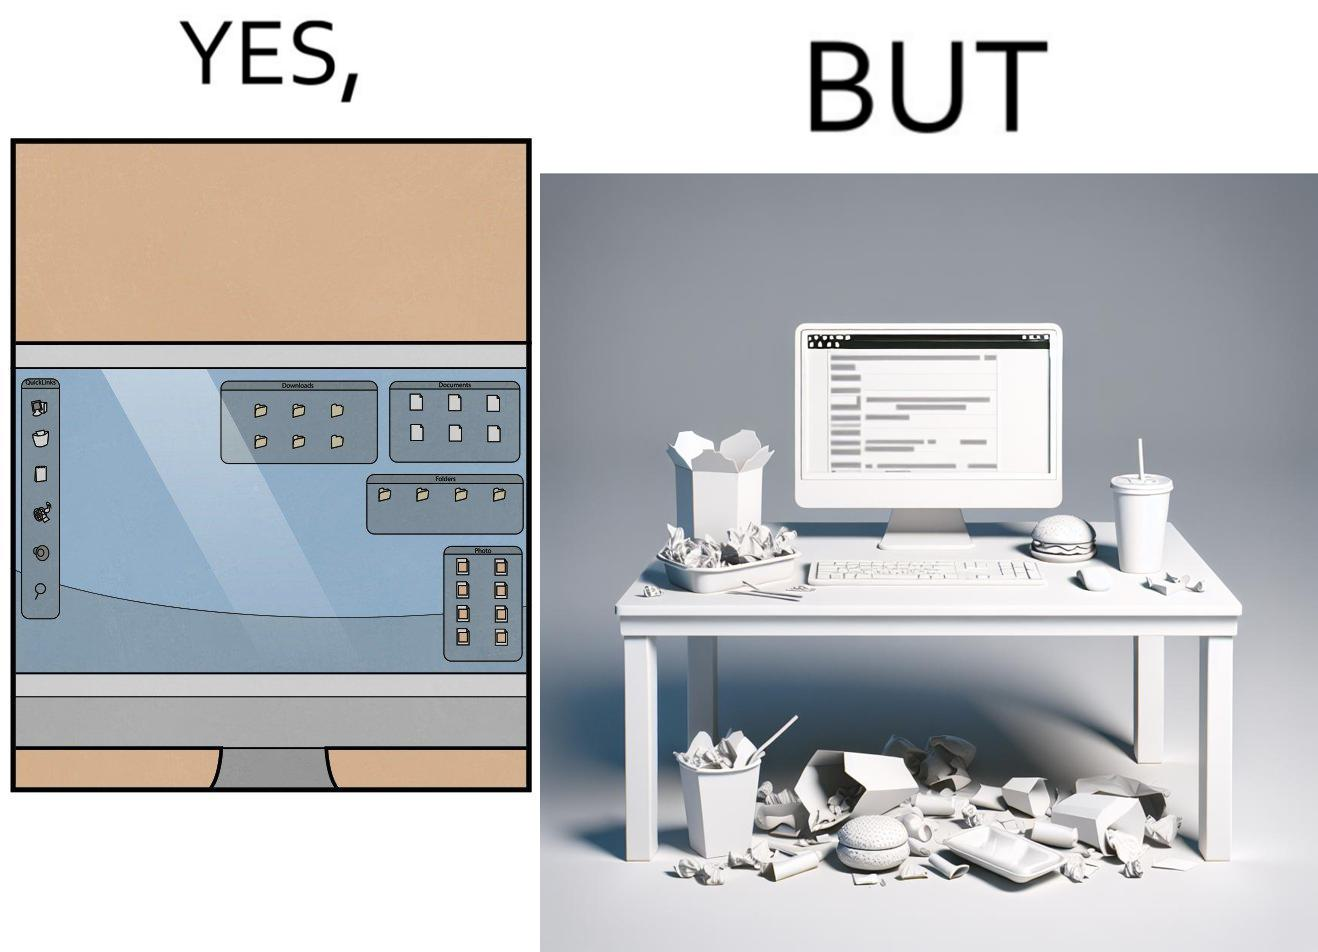Why is this image considered satirical? The image is ironical, as the folder icons on the desktop screen are very neatly arranged, while the person using the computer has littered the table with used food packets, dirty plates, and wrappers. 